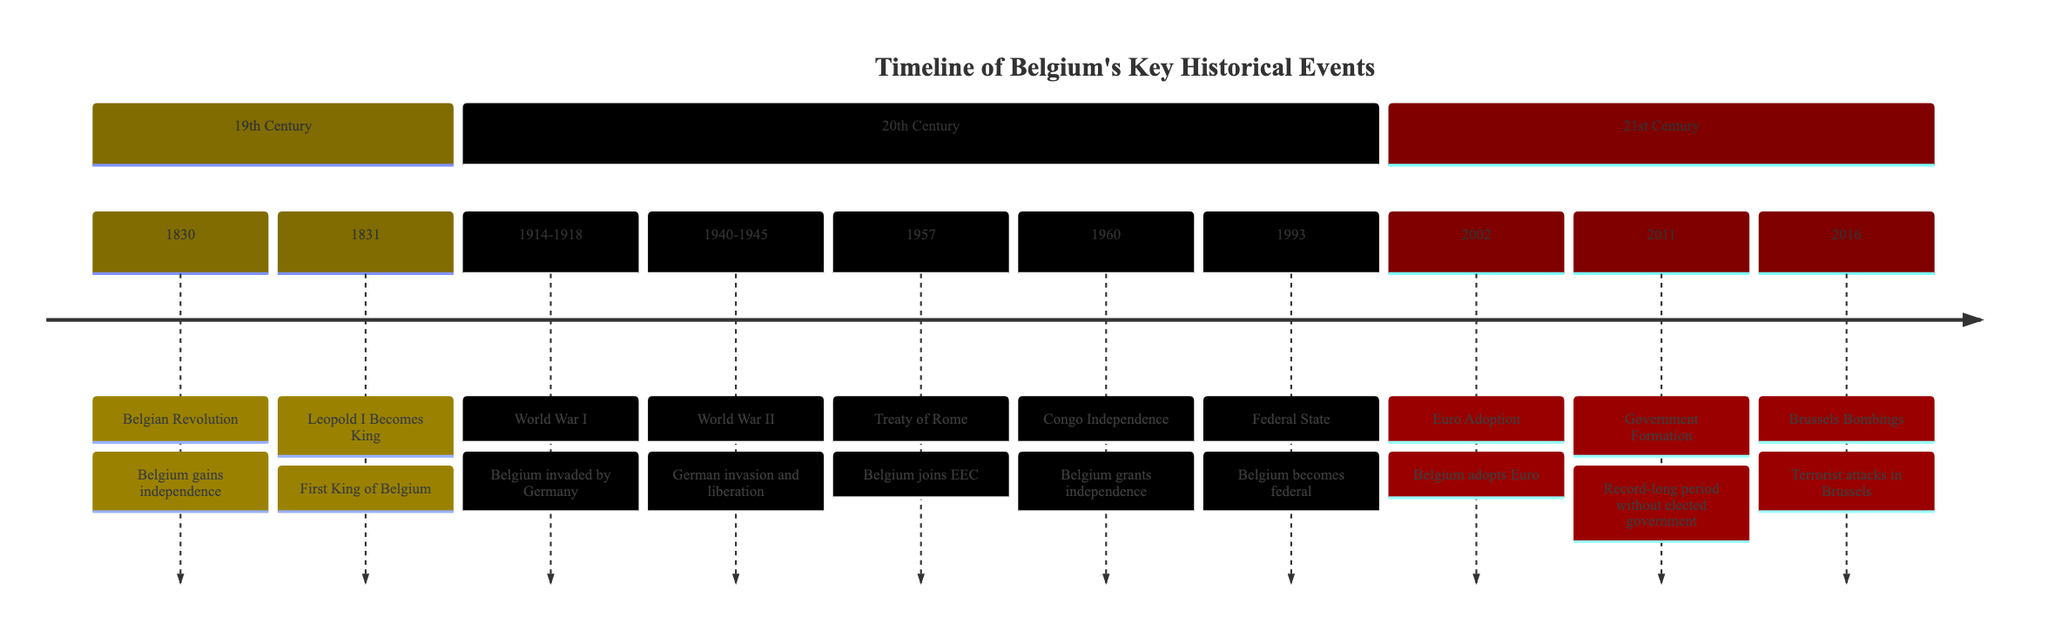What year did Belgium gain independence? The diagram states that the Belgian Revolution occurred in 1830, which led to Belgium gaining independence that same year. Thus, I refer to the timeline to find that event.
Answer: 1830 Who became the first King of Belgium? In 1831, the timeline indicates that Leopold I was instated as the king, making him the first king of Belgium as per the diagram.
Answer: Leopold I In which years did World War I occur? The timeline specifically mentions World War I and aligns it with the years 1914 to 1918 on the timeline, indicating the range of years when this event took place.
Answer: 1914-1918 What significant event happened in Belgium in 1993? According to the timeline, 1993 marks the year Belgium became a federal state. This information is explicitly stated in the diagram.
Answer: Federal State What major international treaty did Belgium join in 1957? The timeline refers to the Treaty of Rome in 1957, which signifies Belgium's joining of the European Economic Community (EEC). This can be identified directly from the section detailing the 20th century.
Answer: Treaty of Rome How many key historical events are shown in the 21st Century section? Reviewing the diagram for the 21st century section, there are three distinct events listed: Euro Adoption in 2002, Government Formation in 2011, and the Brussels Bombings in 2016. Thus, I count these entries in that section to determine the total.
Answer: 3 Which event resulted in Belgium's grant of independence to Congo? The timeline clearly states that in 1960, Belgium granted independence to Congo, which is explicitly noted in the key historical events section.
Answer: Congo Independence What year marks the adoption of the Euro by Belgium? Consulting the timeline, it shows that Belgium adopted the Euro in 2002, providing a specific answer to the queried year.
Answer: 2002 During which years did World War II take place? From the time frame noted in the diagram, World War II is identified with the years 1940 to 1945. By highlighting that section, the specified years are easily visible.
Answer: 1940-1945 